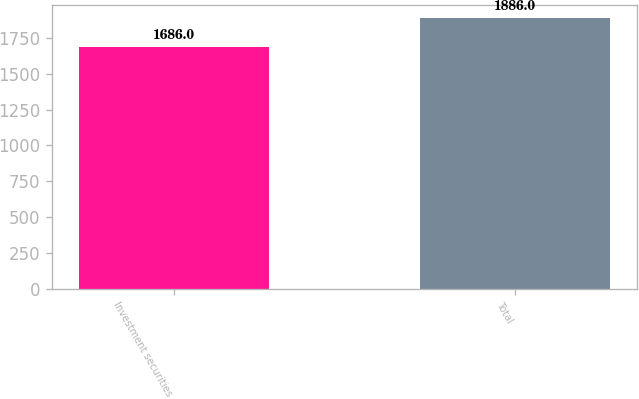<chart> <loc_0><loc_0><loc_500><loc_500><bar_chart><fcel>Investment securities<fcel>Total<nl><fcel>1686<fcel>1886<nl></chart> 